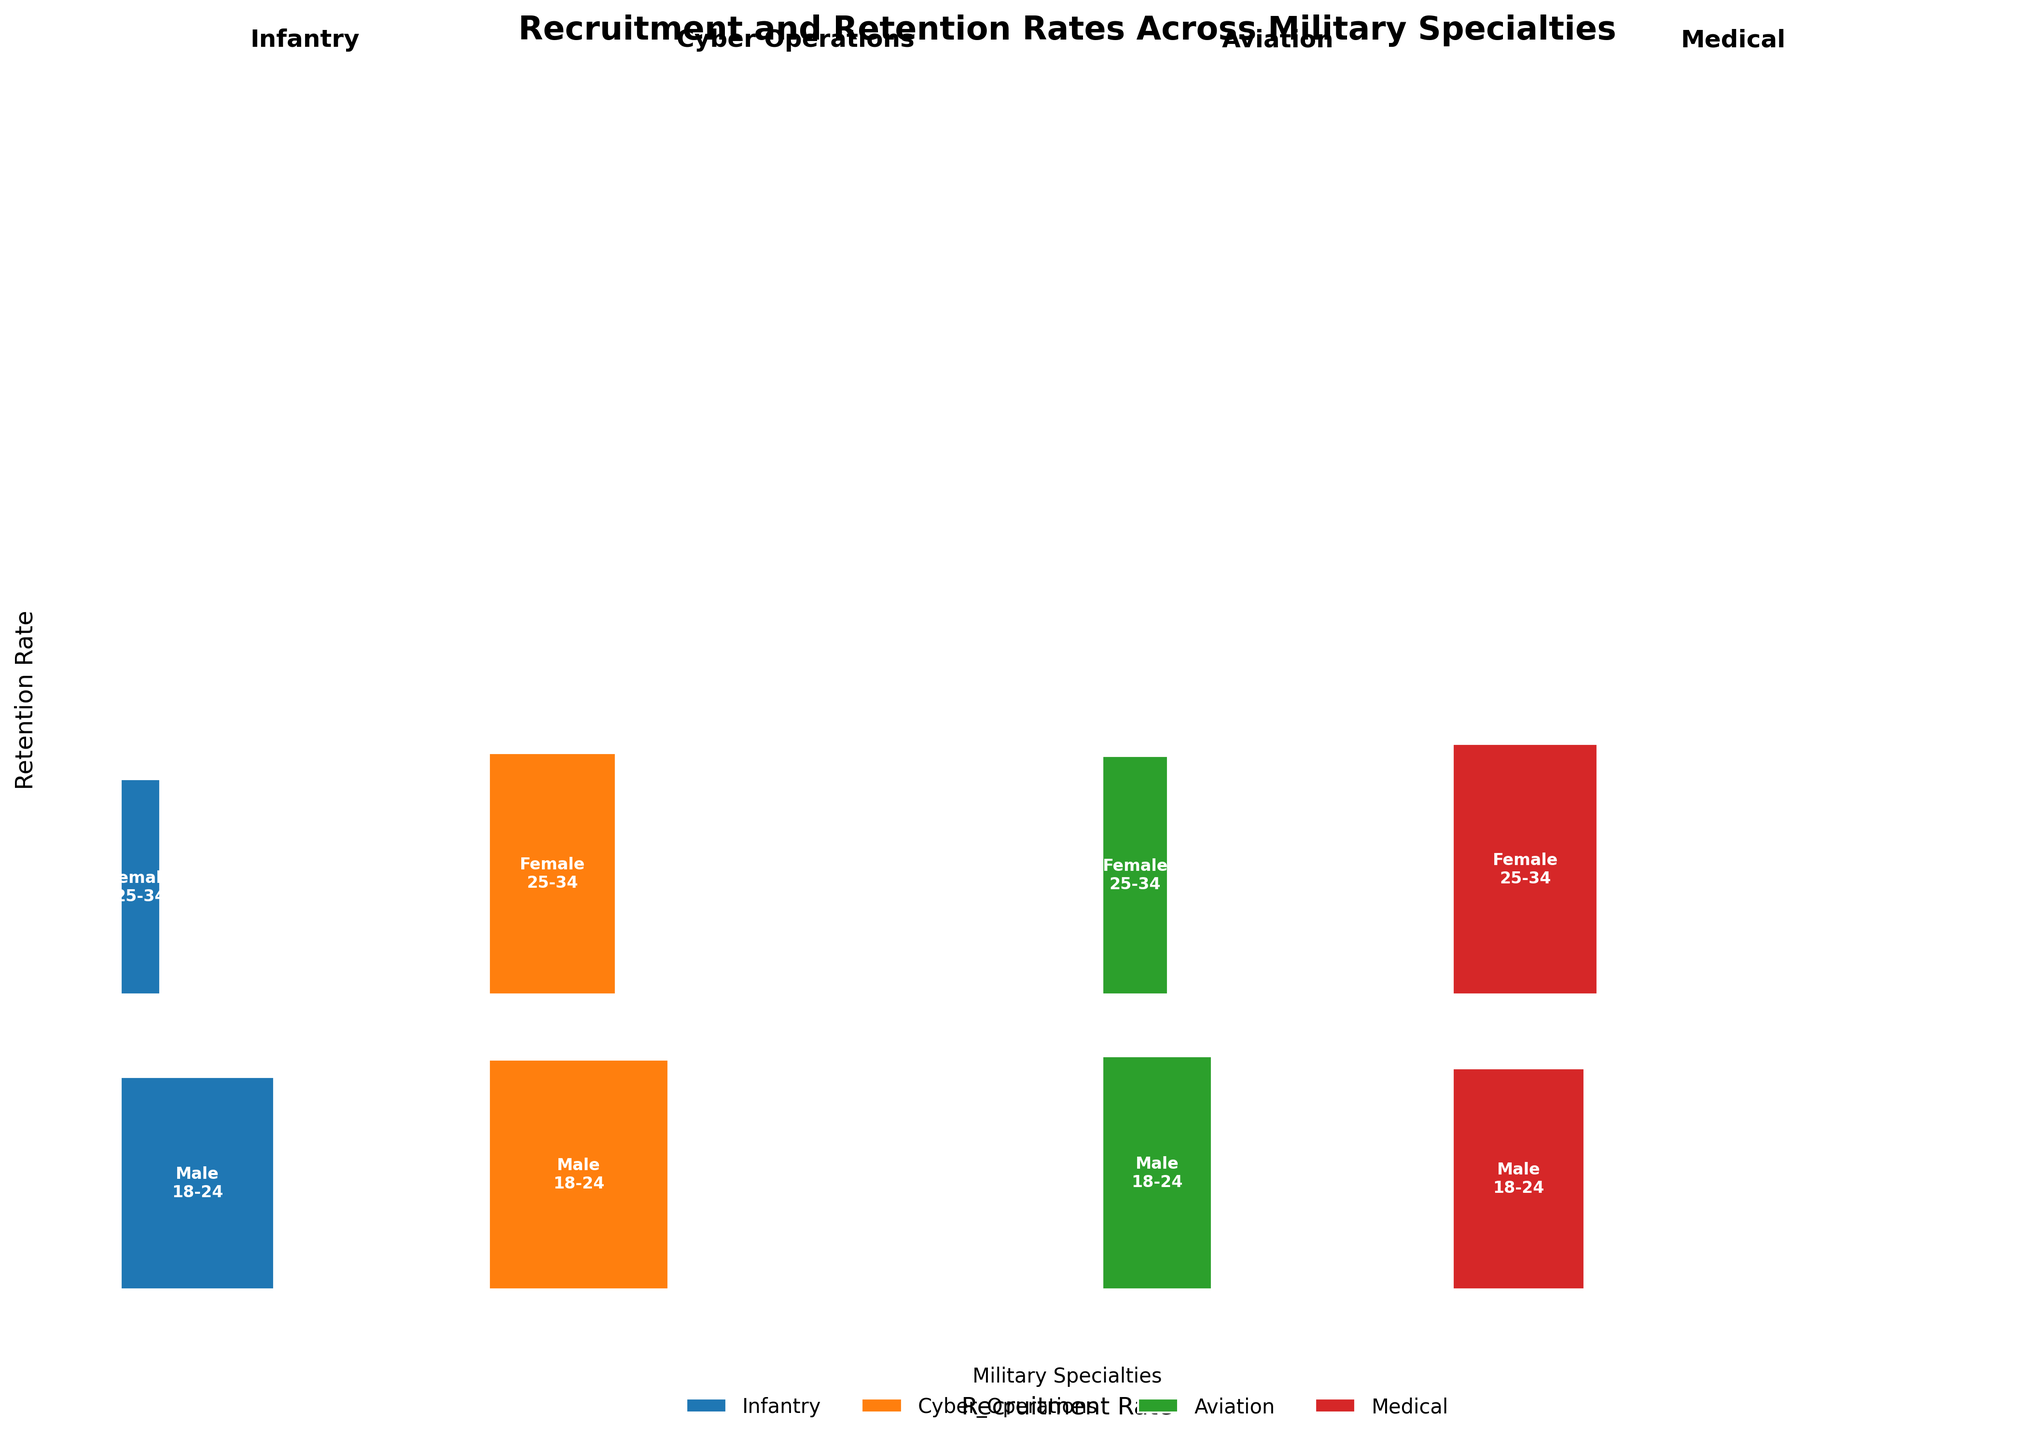What is the title of the plot? The title is often displayed prominently at the top of the plot. By reading the text at the top of the plot, we see that it is labeled "Recruitment and Retention Rates Across Military Specialties".
Answer: Recruitment and Retention Rates Across Military Specialties Which military specialty has the highest recruitment rate for males aged 18-24? To find this, locate the male (18-24) sections for each specialty. The highest recruitment rate amongst all of them appears to correspond to Cyber Operations, where males aged 18-24 have a recruitment rate of 0.41.
Answer: Cyber Operations Compare the retention rates of females aged 25-34 in the Infantry and Medical specialties. Which one is higher? To compare the retention rates, identify the retentions for females aged 25-34 in Infantry and Medical. The retention rate for Infantry is 0.73 while for Medical it is 0.85. Since 0.85 is greater than 0.73, the Medical specialty has a higher retention rate.
Answer: Medical How does the retention rate of males aged 25-34 in Aviation compare to that of males aged 25-34 in Cyber Operations? Locate the retention rates for males aged 25-34 in both specialties. The retention rate is 0.86 for Aviation and 0.85 for Cyber Operations. Hence, the retention rate is slightly higher in Aviation by 0.01.
Answer: Aviation Which gender and age group has the lowest recruitment rate in the Military? By assessing the recruitment rates for all gender and age groups across all specialties, the lowest rate is found for females aged 25-34 in Infantry, with a recruitment rate of 0.09.
Answer: Female, 25-34 What's the difference in recruitment rates between males and females in the 18-24 age group within Infantry? Recruitment rates for Infantry are 0.35 for males and 0.12 for females. Subtracting the lower rate from the higher one, the difference is 0.35 - 0.12 = 0.23.
Answer: 0.23 For which military specialty does the overall recruitment rate (sum across genders and age groups) seem the highest? Calculate the total recruitment rates for each specialty by summing the individual recruitment rates. The calculated sums show: Infantry (0.84), Cyber Operations (1.40), Aviation (0.80), Medical (1.28). Thus, Cyber Operations has the highest overall recruitment rate.
Answer: Cyber Operations What are the two specialties with the highest retention rates among females aged 18-24? By examining the retention rates for females aged 18-24 across all specialties, Cyber Operations has the highest retention rate at 0.76, followed by Medical at 0.79.
Answer: Medical, Cyber Operations Which specialty shows the highest recruitment rate for females overall? Add up recruitment rates for females in each specialty: Infantry (0.21), Cyber Operations (0.61), Aviation (0.33), Medical (0.71). Medical specialty exhibits the highest overall recruitment rate for females with a total of 0.71.
Answer: Medical What specialty has relatively balanced recruitment rates across all demographics, and what does this imply for their recruitment strategy? Balanced recruitment implies nearly equal rates across all segments. Observing the data, Medical specialty has relatively balanced rates among different genders and age groups (0.30 for males 18-24, 0.27 for males 25-34, 0.38 for females 18-24, and 0.33 for females 25-34). This implies that Medical specialty might be implementing an inclusive recruitment strategy.
Answer: Medical 